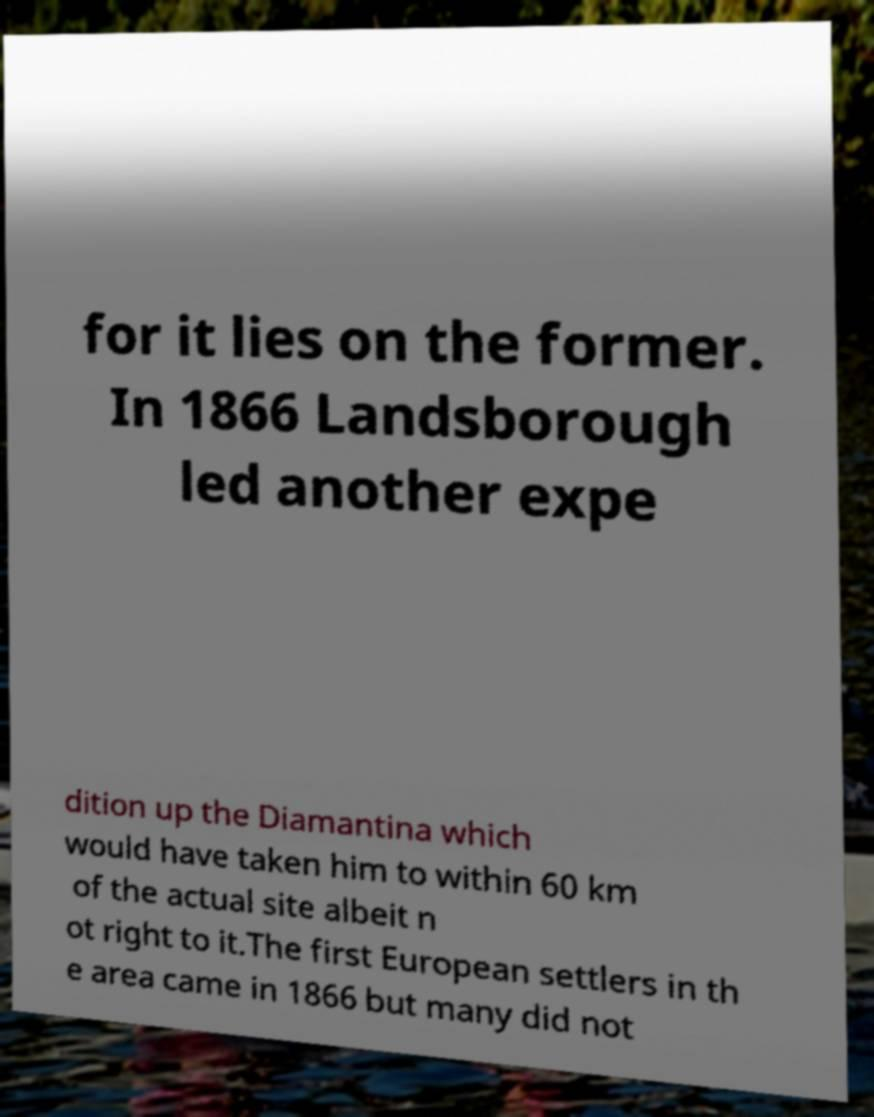For documentation purposes, I need the text within this image transcribed. Could you provide that? for it lies on the former. In 1866 Landsborough led another expe dition up the Diamantina which would have taken him to within 60 km of the actual site albeit n ot right to it.The first European settlers in th e area came in 1866 but many did not 